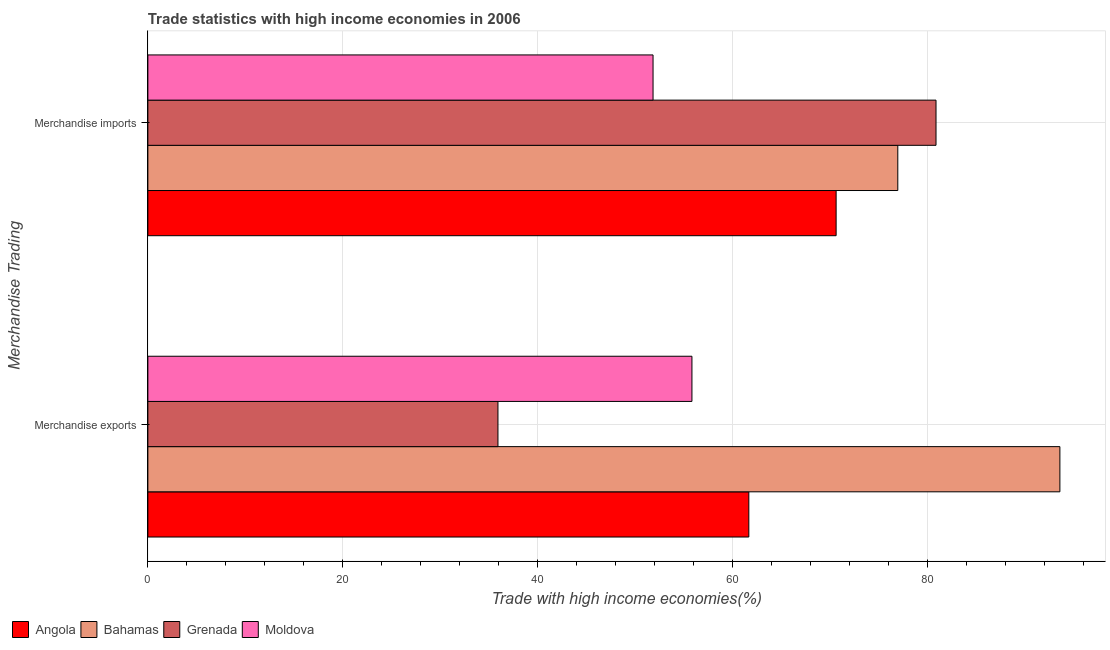How many different coloured bars are there?
Offer a terse response. 4. Are the number of bars on each tick of the Y-axis equal?
Make the answer very short. Yes. What is the merchandise exports in Moldova?
Your response must be concise. 55.85. Across all countries, what is the maximum merchandise exports?
Provide a succinct answer. 93.62. Across all countries, what is the minimum merchandise imports?
Offer a terse response. 51.86. In which country was the merchandise imports maximum?
Your answer should be compact. Grenada. In which country was the merchandise imports minimum?
Offer a terse response. Moldova. What is the total merchandise exports in the graph?
Give a very brief answer. 247.1. What is the difference between the merchandise imports in Moldova and that in Grenada?
Keep it short and to the point. -29.05. What is the difference between the merchandise imports in Bahamas and the merchandise exports in Moldova?
Give a very brief answer. 21.13. What is the average merchandise exports per country?
Your response must be concise. 61.78. What is the difference between the merchandise imports and merchandise exports in Moldova?
Your answer should be very brief. -3.99. In how many countries, is the merchandise imports greater than 16 %?
Your answer should be compact. 4. What is the ratio of the merchandise imports in Moldova to that in Grenada?
Ensure brevity in your answer.  0.64. Is the merchandise exports in Bahamas less than that in Grenada?
Make the answer very short. No. What does the 1st bar from the top in Merchandise exports represents?
Your answer should be very brief. Moldova. What does the 2nd bar from the bottom in Merchandise exports represents?
Offer a very short reply. Bahamas. How many bars are there?
Keep it short and to the point. 8. How many countries are there in the graph?
Give a very brief answer. 4. Are the values on the major ticks of X-axis written in scientific E-notation?
Offer a very short reply. No. How many legend labels are there?
Your answer should be compact. 4. How are the legend labels stacked?
Offer a very short reply. Horizontal. What is the title of the graph?
Keep it short and to the point. Trade statistics with high income economies in 2006. What is the label or title of the X-axis?
Offer a terse response. Trade with high income economies(%). What is the label or title of the Y-axis?
Your response must be concise. Merchandise Trading. What is the Trade with high income economies(%) in Angola in Merchandise exports?
Make the answer very short. 61.69. What is the Trade with high income economies(%) in Bahamas in Merchandise exports?
Your answer should be very brief. 93.62. What is the Trade with high income economies(%) of Grenada in Merchandise exports?
Keep it short and to the point. 35.94. What is the Trade with high income economies(%) in Moldova in Merchandise exports?
Offer a very short reply. 55.85. What is the Trade with high income economies(%) of Angola in Merchandise imports?
Make the answer very short. 70.65. What is the Trade with high income economies(%) in Bahamas in Merchandise imports?
Your answer should be compact. 76.98. What is the Trade with high income economies(%) of Grenada in Merchandise imports?
Your answer should be very brief. 80.91. What is the Trade with high income economies(%) of Moldova in Merchandise imports?
Ensure brevity in your answer.  51.86. Across all Merchandise Trading, what is the maximum Trade with high income economies(%) in Angola?
Keep it short and to the point. 70.65. Across all Merchandise Trading, what is the maximum Trade with high income economies(%) in Bahamas?
Offer a terse response. 93.62. Across all Merchandise Trading, what is the maximum Trade with high income economies(%) of Grenada?
Your answer should be very brief. 80.91. Across all Merchandise Trading, what is the maximum Trade with high income economies(%) of Moldova?
Provide a succinct answer. 55.85. Across all Merchandise Trading, what is the minimum Trade with high income economies(%) in Angola?
Make the answer very short. 61.69. Across all Merchandise Trading, what is the minimum Trade with high income economies(%) in Bahamas?
Ensure brevity in your answer.  76.98. Across all Merchandise Trading, what is the minimum Trade with high income economies(%) of Grenada?
Provide a succinct answer. 35.94. Across all Merchandise Trading, what is the minimum Trade with high income economies(%) of Moldova?
Make the answer very short. 51.86. What is the total Trade with high income economies(%) in Angola in the graph?
Keep it short and to the point. 132.34. What is the total Trade with high income economies(%) in Bahamas in the graph?
Your answer should be compact. 170.6. What is the total Trade with high income economies(%) in Grenada in the graph?
Your answer should be very brief. 116.84. What is the total Trade with high income economies(%) in Moldova in the graph?
Ensure brevity in your answer.  107.71. What is the difference between the Trade with high income economies(%) in Angola in Merchandise exports and that in Merchandise imports?
Your answer should be very brief. -8.96. What is the difference between the Trade with high income economies(%) in Bahamas in Merchandise exports and that in Merchandise imports?
Ensure brevity in your answer.  16.64. What is the difference between the Trade with high income economies(%) in Grenada in Merchandise exports and that in Merchandise imports?
Offer a terse response. -44.97. What is the difference between the Trade with high income economies(%) of Moldova in Merchandise exports and that in Merchandise imports?
Keep it short and to the point. 3.99. What is the difference between the Trade with high income economies(%) in Angola in Merchandise exports and the Trade with high income economies(%) in Bahamas in Merchandise imports?
Your answer should be very brief. -15.29. What is the difference between the Trade with high income economies(%) in Angola in Merchandise exports and the Trade with high income economies(%) in Grenada in Merchandise imports?
Provide a short and direct response. -19.22. What is the difference between the Trade with high income economies(%) in Angola in Merchandise exports and the Trade with high income economies(%) in Moldova in Merchandise imports?
Your answer should be very brief. 9.83. What is the difference between the Trade with high income economies(%) of Bahamas in Merchandise exports and the Trade with high income economies(%) of Grenada in Merchandise imports?
Your answer should be compact. 12.72. What is the difference between the Trade with high income economies(%) of Bahamas in Merchandise exports and the Trade with high income economies(%) of Moldova in Merchandise imports?
Your answer should be very brief. 41.76. What is the difference between the Trade with high income economies(%) of Grenada in Merchandise exports and the Trade with high income economies(%) of Moldova in Merchandise imports?
Ensure brevity in your answer.  -15.92. What is the average Trade with high income economies(%) in Angola per Merchandise Trading?
Provide a short and direct response. 66.17. What is the average Trade with high income economies(%) in Bahamas per Merchandise Trading?
Provide a succinct answer. 85.3. What is the average Trade with high income economies(%) in Grenada per Merchandise Trading?
Give a very brief answer. 58.42. What is the average Trade with high income economies(%) in Moldova per Merchandise Trading?
Give a very brief answer. 53.85. What is the difference between the Trade with high income economies(%) in Angola and Trade with high income economies(%) in Bahamas in Merchandise exports?
Your answer should be compact. -31.93. What is the difference between the Trade with high income economies(%) of Angola and Trade with high income economies(%) of Grenada in Merchandise exports?
Provide a short and direct response. 25.75. What is the difference between the Trade with high income economies(%) of Angola and Trade with high income economies(%) of Moldova in Merchandise exports?
Your response must be concise. 5.84. What is the difference between the Trade with high income economies(%) of Bahamas and Trade with high income economies(%) of Grenada in Merchandise exports?
Give a very brief answer. 57.68. What is the difference between the Trade with high income economies(%) of Bahamas and Trade with high income economies(%) of Moldova in Merchandise exports?
Offer a very short reply. 37.77. What is the difference between the Trade with high income economies(%) in Grenada and Trade with high income economies(%) in Moldova in Merchandise exports?
Ensure brevity in your answer.  -19.91. What is the difference between the Trade with high income economies(%) in Angola and Trade with high income economies(%) in Bahamas in Merchandise imports?
Your answer should be very brief. -6.33. What is the difference between the Trade with high income economies(%) in Angola and Trade with high income economies(%) in Grenada in Merchandise imports?
Give a very brief answer. -10.25. What is the difference between the Trade with high income economies(%) of Angola and Trade with high income economies(%) of Moldova in Merchandise imports?
Your answer should be very brief. 18.79. What is the difference between the Trade with high income economies(%) of Bahamas and Trade with high income economies(%) of Grenada in Merchandise imports?
Your answer should be compact. -3.92. What is the difference between the Trade with high income economies(%) of Bahamas and Trade with high income economies(%) of Moldova in Merchandise imports?
Offer a very short reply. 25.12. What is the difference between the Trade with high income economies(%) in Grenada and Trade with high income economies(%) in Moldova in Merchandise imports?
Provide a short and direct response. 29.05. What is the ratio of the Trade with high income economies(%) in Angola in Merchandise exports to that in Merchandise imports?
Give a very brief answer. 0.87. What is the ratio of the Trade with high income economies(%) in Bahamas in Merchandise exports to that in Merchandise imports?
Ensure brevity in your answer.  1.22. What is the ratio of the Trade with high income economies(%) in Grenada in Merchandise exports to that in Merchandise imports?
Give a very brief answer. 0.44. What is the ratio of the Trade with high income economies(%) in Moldova in Merchandise exports to that in Merchandise imports?
Your response must be concise. 1.08. What is the difference between the highest and the second highest Trade with high income economies(%) of Angola?
Make the answer very short. 8.96. What is the difference between the highest and the second highest Trade with high income economies(%) in Bahamas?
Your answer should be compact. 16.64. What is the difference between the highest and the second highest Trade with high income economies(%) in Grenada?
Provide a succinct answer. 44.97. What is the difference between the highest and the second highest Trade with high income economies(%) of Moldova?
Your answer should be very brief. 3.99. What is the difference between the highest and the lowest Trade with high income economies(%) of Angola?
Offer a terse response. 8.96. What is the difference between the highest and the lowest Trade with high income economies(%) of Bahamas?
Offer a very short reply. 16.64. What is the difference between the highest and the lowest Trade with high income economies(%) of Grenada?
Your answer should be compact. 44.97. What is the difference between the highest and the lowest Trade with high income economies(%) in Moldova?
Give a very brief answer. 3.99. 